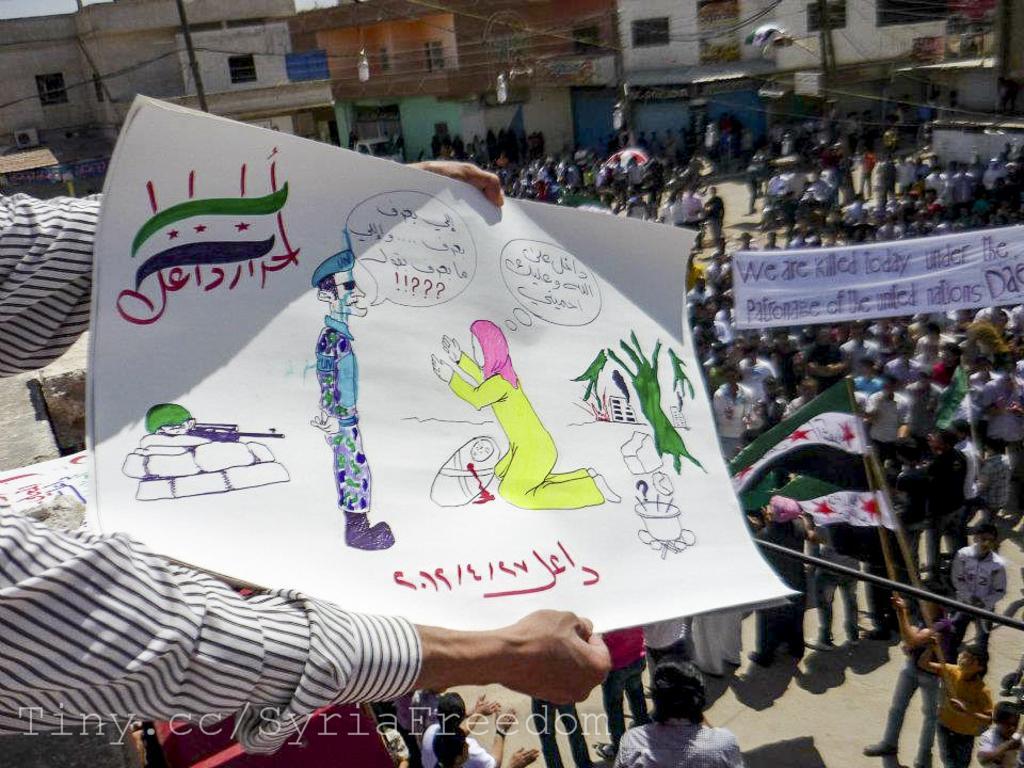How would you summarize this image in a sentence or two? In this picture I can see few people standing, they are holding a banner with some text and and couple of them holding flags in their hands and I can see buildings and poles and a man holding a placard with some pictures and text on it and I can see text at the bottom left corner of the picture. 